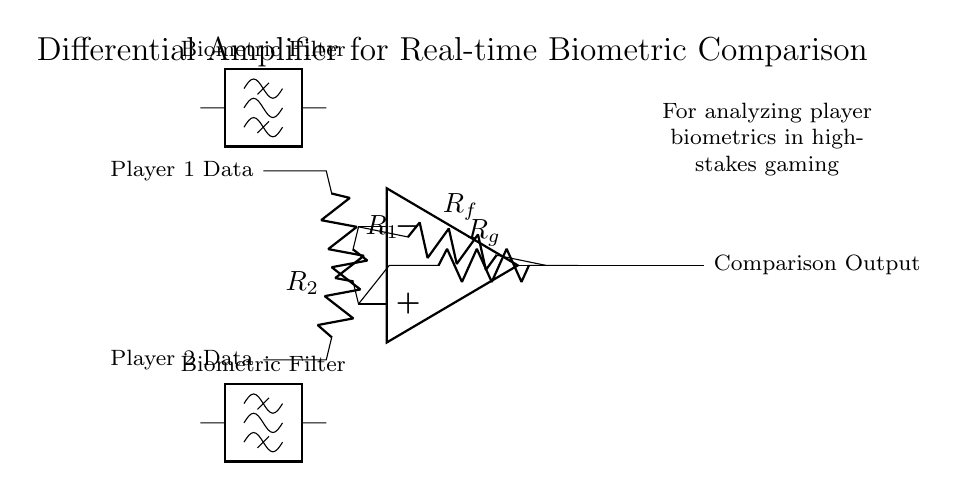What type of amplifier is represented in the circuit? The circuit is a differential amplifier, characterized by its ability to amplify the difference between two input signals while rejecting common-mode noise. This is evident from the configuration of the operational amplifier and the presence of two resistors connected to the inputs.
Answer: differential amplifier What do the resistors R1 and R2 represent? Resistors R1 and R2 are the input resistors connected to Player 1 and Player 2 biometric data, respectively. Their function is to set the input impedance of the amplifier and influence the gain of the amplifier based on their values in relation to the feedback resistors.
Answer: input resistors What is the role of Rf in this circuit? Rf is the feedback resistor in the circuit that determines the overall gain of the differential amplifier by providing feedback from the output to the inverting input. This affects the amplification of the voltage difference between the two player data inputs.
Answer: feedback resistor How many biometric filters are present in the circuit? Two biometric filters are present, one for each player's data input, helping to filter out noise and ensure the important signals are amplified correctly. Each filter connects to its respective input resistor before reaching the operational amplifier.
Answer: two What is the expected output of this circuit? The expected output is the comparison of the two players' biometric data, represented as a voltage signal at the output of the amplifier that indicates the difference in their biometric measurements. This output can then be used for analysis or decision-making in gaming scenarios.
Answer: comparison output What is the significance of common-mode rejection in this circuit? Common-mode rejection is significant because it allows the differential amplifier to focus on the difference between Player 1 and Player 2's data while ignoring noise and variations that are the same for both inputs, thus improving the reliability of the comparison in high-stakes environments.
Answer: improves reliability 